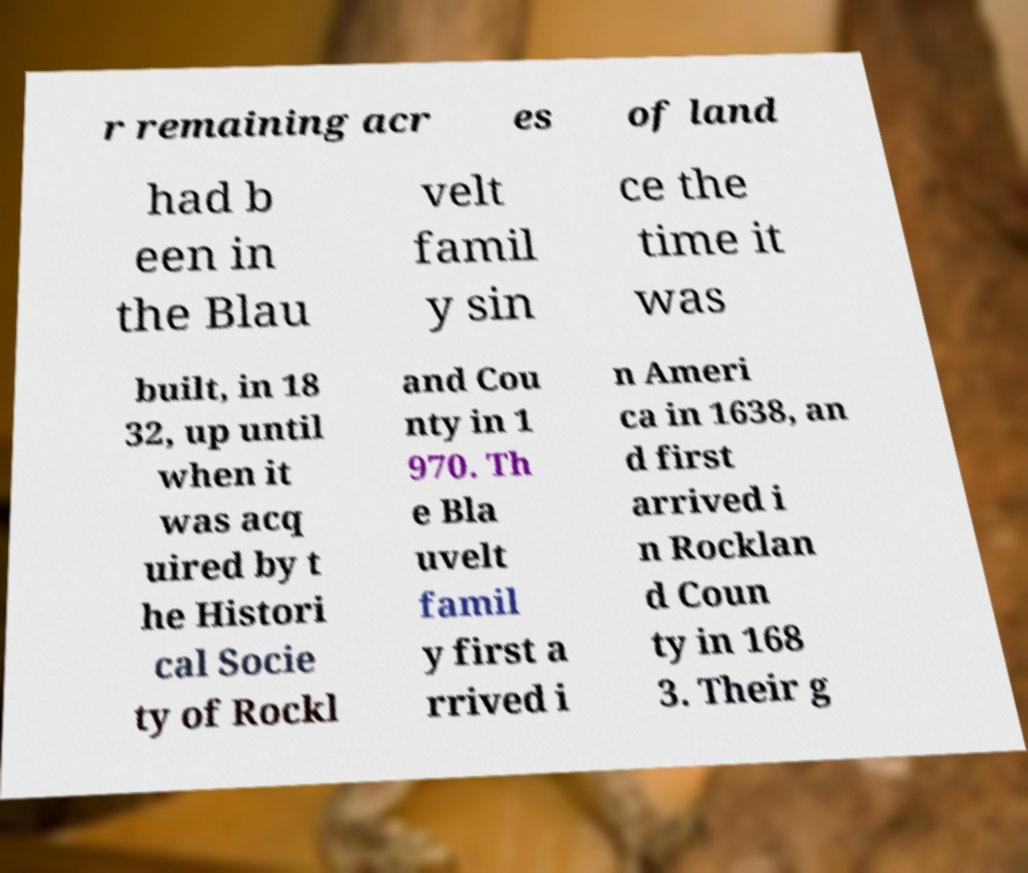Please read and relay the text visible in this image. What does it say? r remaining acr es of land had b een in the Blau velt famil y sin ce the time it was built, in 18 32, up until when it was acq uired by t he Histori cal Socie ty of Rockl and Cou nty in 1 970. Th e Bla uvelt famil y first a rrived i n Ameri ca in 1638, an d first arrived i n Rocklan d Coun ty in 168 3. Their g 